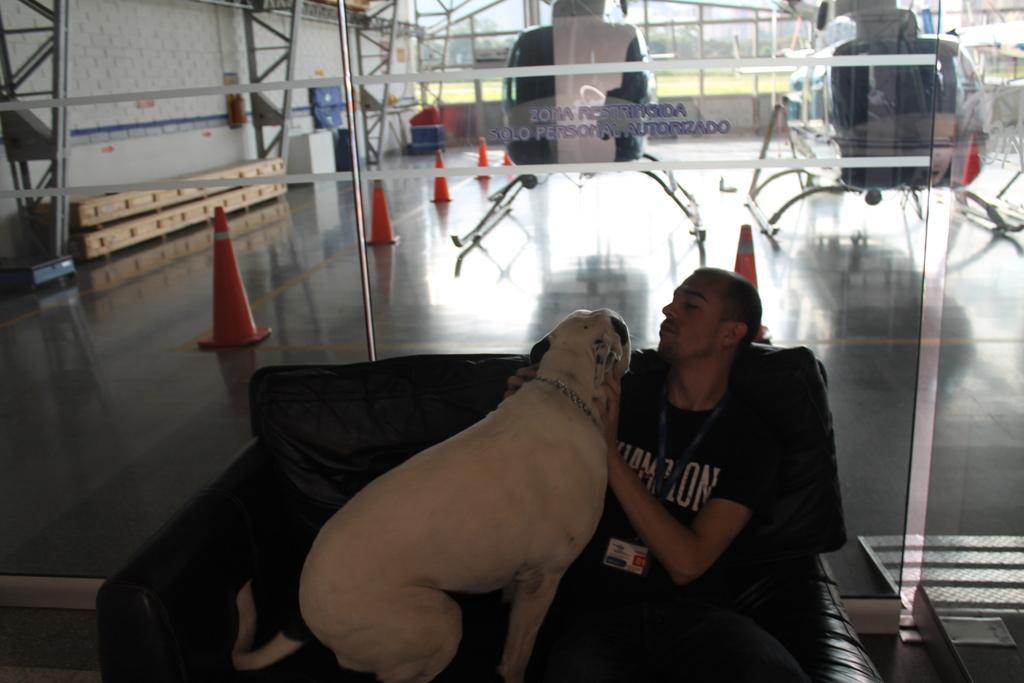Can you describe this image briefly? In this picture there is a man sitting on the chair and holding a dog. There are traffic cones. There are helicopters at the background. 